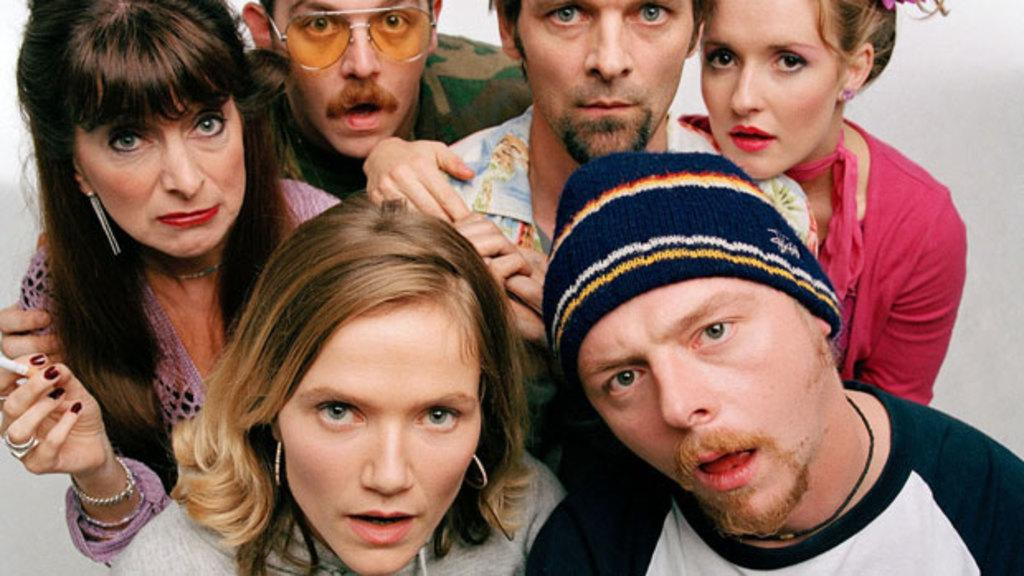Who or what is present in the image? There are people in the image. What can be observed about the background of the image? The background of the image is white. What type of boot is being worn by the people in the image? There is no information about boots or footwear in the image, so it cannot be determined from the image. 